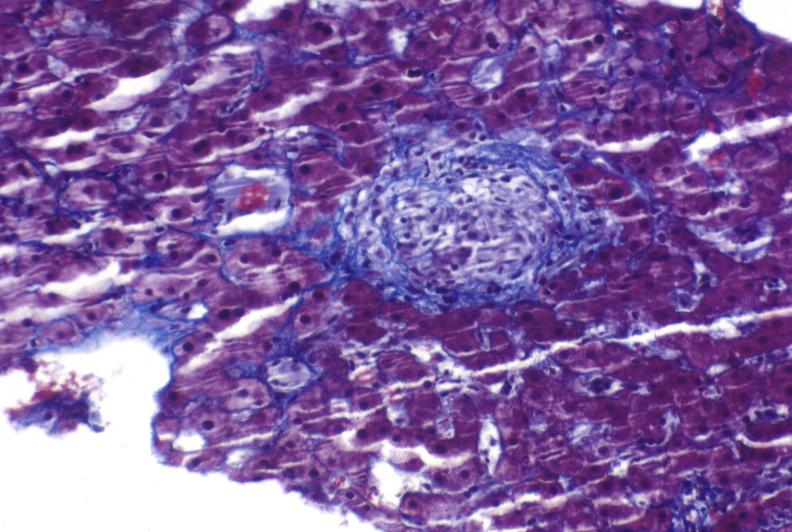what is present?
Answer the question using a single word or phrase. Liver 